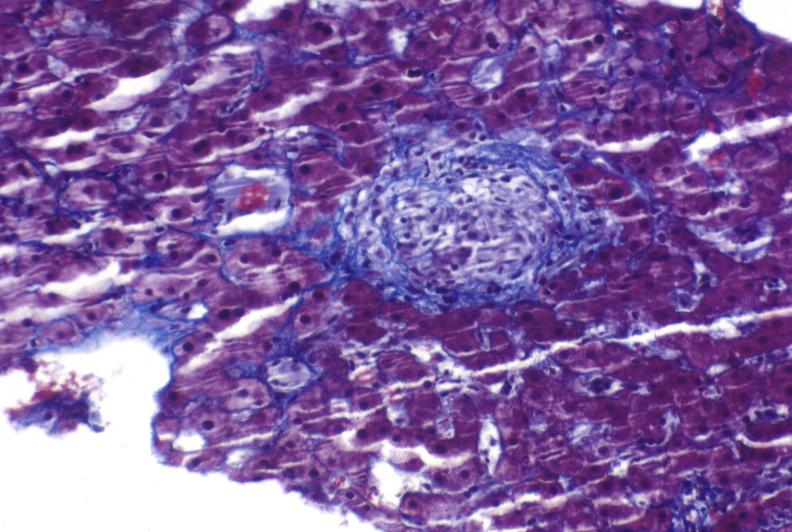what is present?
Answer the question using a single word or phrase. Liver 